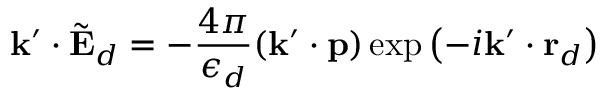Convert formula to latex. <formula><loc_0><loc_0><loc_500><loc_500>k ^ { \prime } \cdot \tilde { E } _ { d } = - \frac { 4 \pi } { \epsilon _ { d } } ( k ^ { \prime } \cdot p ) \exp \left ( - i k ^ { \prime } \cdot r _ { d } \right )</formula> 